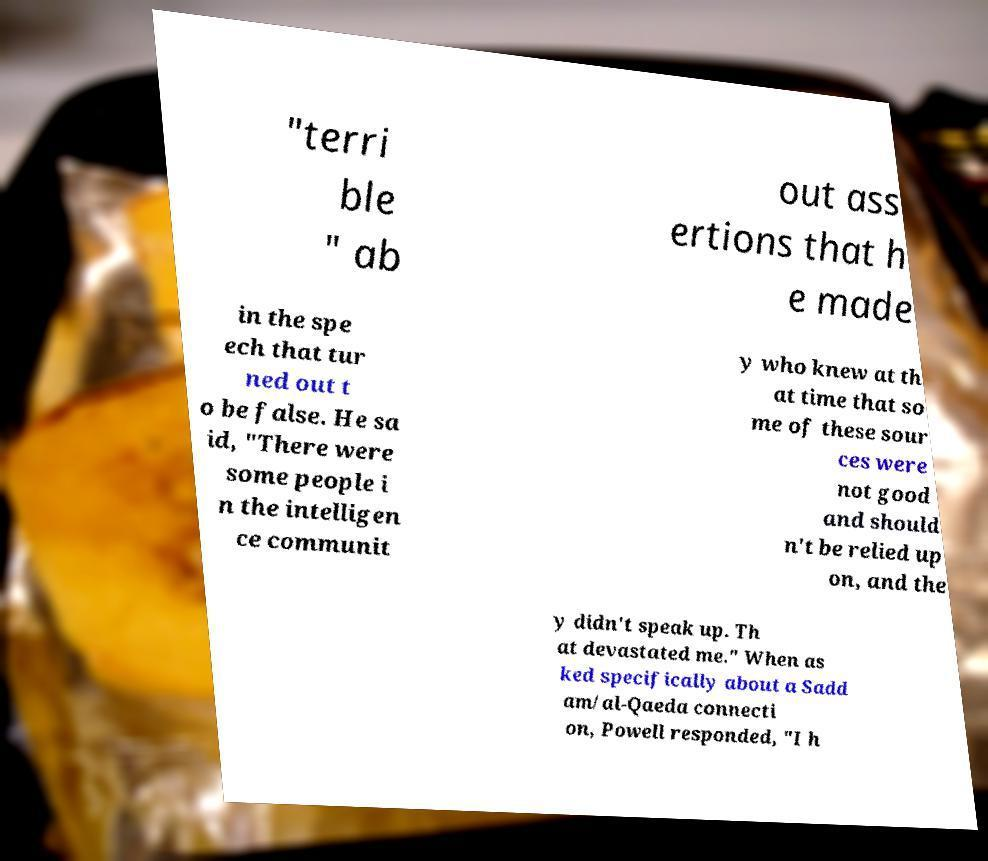What messages or text are displayed in this image? I need them in a readable, typed format. "terri ble " ab out ass ertions that h e made in the spe ech that tur ned out t o be false. He sa id, "There were some people i n the intelligen ce communit y who knew at th at time that so me of these sour ces were not good and should n't be relied up on, and the y didn't speak up. Th at devastated me." When as ked specifically about a Sadd am/al-Qaeda connecti on, Powell responded, "I h 